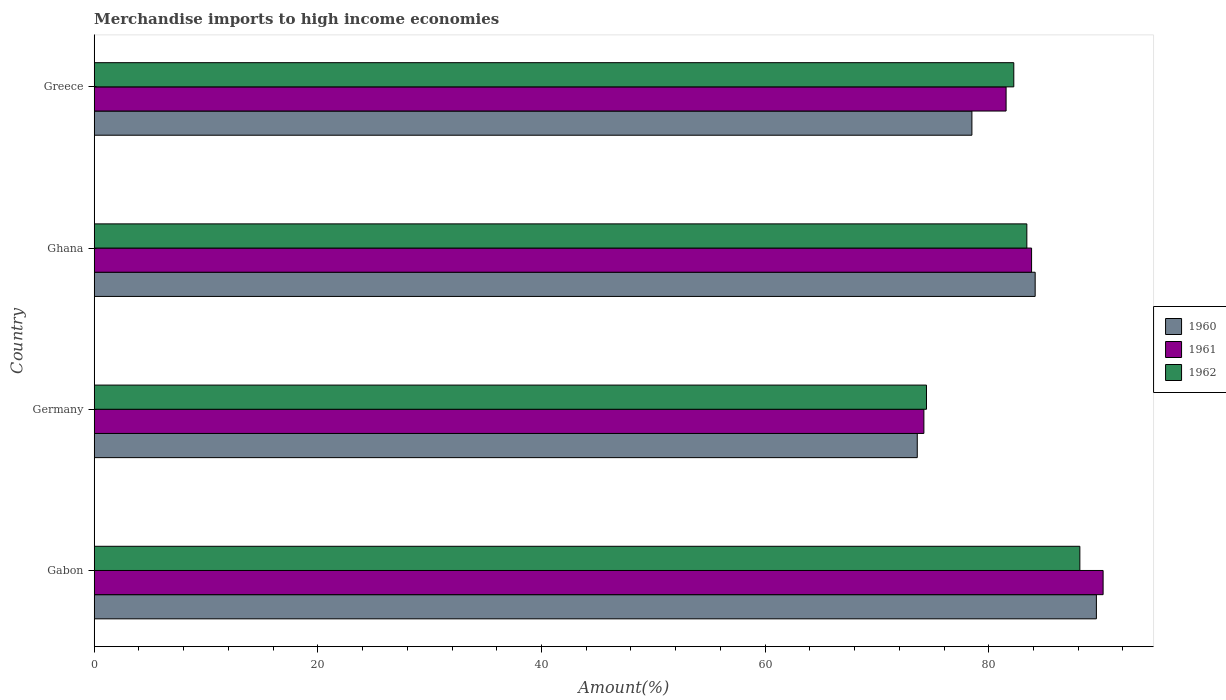How many groups of bars are there?
Ensure brevity in your answer.  4. Are the number of bars per tick equal to the number of legend labels?
Provide a short and direct response. Yes. What is the label of the 3rd group of bars from the top?
Ensure brevity in your answer.  Germany. What is the percentage of amount earned from merchandise imports in 1961 in Gabon?
Your answer should be compact. 90.22. Across all countries, what is the maximum percentage of amount earned from merchandise imports in 1961?
Offer a very short reply. 90.22. Across all countries, what is the minimum percentage of amount earned from merchandise imports in 1961?
Offer a very short reply. 74.2. In which country was the percentage of amount earned from merchandise imports in 1960 maximum?
Provide a short and direct response. Gabon. What is the total percentage of amount earned from merchandise imports in 1961 in the graph?
Offer a very short reply. 329.79. What is the difference between the percentage of amount earned from merchandise imports in 1961 in Gabon and that in Greece?
Offer a very short reply. 8.68. What is the difference between the percentage of amount earned from merchandise imports in 1961 in Gabon and the percentage of amount earned from merchandise imports in 1960 in Germany?
Offer a terse response. 16.62. What is the average percentage of amount earned from merchandise imports in 1960 per country?
Your response must be concise. 81.47. What is the difference between the percentage of amount earned from merchandise imports in 1962 and percentage of amount earned from merchandise imports in 1960 in Ghana?
Offer a very short reply. -0.74. In how many countries, is the percentage of amount earned from merchandise imports in 1960 greater than 52 %?
Provide a short and direct response. 4. What is the ratio of the percentage of amount earned from merchandise imports in 1960 in Germany to that in Greece?
Ensure brevity in your answer.  0.94. Is the percentage of amount earned from merchandise imports in 1961 in Gabon less than that in Greece?
Ensure brevity in your answer.  No. Is the difference between the percentage of amount earned from merchandise imports in 1962 in Gabon and Germany greater than the difference between the percentage of amount earned from merchandise imports in 1960 in Gabon and Germany?
Make the answer very short. No. What is the difference between the highest and the second highest percentage of amount earned from merchandise imports in 1961?
Your answer should be compact. 6.4. What is the difference between the highest and the lowest percentage of amount earned from merchandise imports in 1962?
Offer a terse response. 13.72. Is the sum of the percentage of amount earned from merchandise imports in 1962 in Germany and Ghana greater than the maximum percentage of amount earned from merchandise imports in 1960 across all countries?
Make the answer very short. Yes. What does the 2nd bar from the bottom in Greece represents?
Your response must be concise. 1961. Is it the case that in every country, the sum of the percentage of amount earned from merchandise imports in 1960 and percentage of amount earned from merchandise imports in 1962 is greater than the percentage of amount earned from merchandise imports in 1961?
Provide a short and direct response. Yes. How many bars are there?
Give a very brief answer. 12. Are all the bars in the graph horizontal?
Provide a short and direct response. Yes. What is the difference between two consecutive major ticks on the X-axis?
Offer a very short reply. 20. Are the values on the major ticks of X-axis written in scientific E-notation?
Your answer should be compact. No. Where does the legend appear in the graph?
Provide a succinct answer. Center right. How many legend labels are there?
Give a very brief answer. 3. How are the legend labels stacked?
Provide a succinct answer. Vertical. What is the title of the graph?
Your response must be concise. Merchandise imports to high income economies. What is the label or title of the X-axis?
Offer a very short reply. Amount(%). What is the Amount(%) in 1960 in Gabon?
Your answer should be very brief. 89.62. What is the Amount(%) of 1961 in Gabon?
Your answer should be very brief. 90.22. What is the Amount(%) of 1962 in Gabon?
Offer a very short reply. 88.14. What is the Amount(%) in 1960 in Germany?
Ensure brevity in your answer.  73.6. What is the Amount(%) in 1961 in Germany?
Your answer should be compact. 74.2. What is the Amount(%) in 1962 in Germany?
Provide a succinct answer. 74.43. What is the Amount(%) of 1960 in Ghana?
Make the answer very short. 84.15. What is the Amount(%) of 1961 in Ghana?
Your response must be concise. 83.83. What is the Amount(%) of 1962 in Ghana?
Your answer should be very brief. 83.4. What is the Amount(%) in 1960 in Greece?
Keep it short and to the point. 78.49. What is the Amount(%) in 1961 in Greece?
Keep it short and to the point. 81.55. What is the Amount(%) of 1962 in Greece?
Offer a terse response. 82.24. Across all countries, what is the maximum Amount(%) in 1960?
Make the answer very short. 89.62. Across all countries, what is the maximum Amount(%) in 1961?
Offer a very short reply. 90.22. Across all countries, what is the maximum Amount(%) of 1962?
Provide a short and direct response. 88.14. Across all countries, what is the minimum Amount(%) of 1960?
Ensure brevity in your answer.  73.6. Across all countries, what is the minimum Amount(%) in 1961?
Offer a very short reply. 74.2. Across all countries, what is the minimum Amount(%) in 1962?
Offer a terse response. 74.43. What is the total Amount(%) of 1960 in the graph?
Offer a very short reply. 325.87. What is the total Amount(%) of 1961 in the graph?
Provide a short and direct response. 329.79. What is the total Amount(%) of 1962 in the graph?
Provide a short and direct response. 328.21. What is the difference between the Amount(%) of 1960 in Gabon and that in Germany?
Make the answer very short. 16.02. What is the difference between the Amount(%) in 1961 in Gabon and that in Germany?
Make the answer very short. 16.03. What is the difference between the Amount(%) of 1962 in Gabon and that in Germany?
Your answer should be very brief. 13.72. What is the difference between the Amount(%) of 1960 in Gabon and that in Ghana?
Make the answer very short. 5.47. What is the difference between the Amount(%) of 1961 in Gabon and that in Ghana?
Ensure brevity in your answer.  6.4. What is the difference between the Amount(%) of 1962 in Gabon and that in Ghana?
Ensure brevity in your answer.  4.74. What is the difference between the Amount(%) of 1960 in Gabon and that in Greece?
Keep it short and to the point. 11.13. What is the difference between the Amount(%) of 1961 in Gabon and that in Greece?
Keep it short and to the point. 8.68. What is the difference between the Amount(%) in 1962 in Gabon and that in Greece?
Offer a terse response. 5.91. What is the difference between the Amount(%) of 1960 in Germany and that in Ghana?
Your answer should be compact. -10.54. What is the difference between the Amount(%) in 1961 in Germany and that in Ghana?
Provide a succinct answer. -9.63. What is the difference between the Amount(%) in 1962 in Germany and that in Ghana?
Ensure brevity in your answer.  -8.98. What is the difference between the Amount(%) in 1960 in Germany and that in Greece?
Provide a short and direct response. -4.89. What is the difference between the Amount(%) of 1961 in Germany and that in Greece?
Your answer should be very brief. -7.35. What is the difference between the Amount(%) in 1962 in Germany and that in Greece?
Provide a succinct answer. -7.81. What is the difference between the Amount(%) of 1960 in Ghana and that in Greece?
Keep it short and to the point. 5.66. What is the difference between the Amount(%) in 1961 in Ghana and that in Greece?
Provide a short and direct response. 2.28. What is the difference between the Amount(%) of 1962 in Ghana and that in Greece?
Your answer should be compact. 1.17. What is the difference between the Amount(%) of 1960 in Gabon and the Amount(%) of 1961 in Germany?
Your answer should be very brief. 15.43. What is the difference between the Amount(%) of 1960 in Gabon and the Amount(%) of 1962 in Germany?
Ensure brevity in your answer.  15.19. What is the difference between the Amount(%) in 1961 in Gabon and the Amount(%) in 1962 in Germany?
Provide a succinct answer. 15.8. What is the difference between the Amount(%) in 1960 in Gabon and the Amount(%) in 1961 in Ghana?
Your response must be concise. 5.8. What is the difference between the Amount(%) of 1960 in Gabon and the Amount(%) of 1962 in Ghana?
Offer a very short reply. 6.22. What is the difference between the Amount(%) in 1961 in Gabon and the Amount(%) in 1962 in Ghana?
Make the answer very short. 6.82. What is the difference between the Amount(%) of 1960 in Gabon and the Amount(%) of 1961 in Greece?
Offer a very short reply. 8.07. What is the difference between the Amount(%) of 1960 in Gabon and the Amount(%) of 1962 in Greece?
Make the answer very short. 7.39. What is the difference between the Amount(%) of 1961 in Gabon and the Amount(%) of 1962 in Greece?
Ensure brevity in your answer.  7.99. What is the difference between the Amount(%) of 1960 in Germany and the Amount(%) of 1961 in Ghana?
Provide a short and direct response. -10.22. What is the difference between the Amount(%) in 1960 in Germany and the Amount(%) in 1962 in Ghana?
Your response must be concise. -9.8. What is the difference between the Amount(%) in 1961 in Germany and the Amount(%) in 1962 in Ghana?
Your answer should be very brief. -9.21. What is the difference between the Amount(%) of 1960 in Germany and the Amount(%) of 1961 in Greece?
Your answer should be compact. -7.94. What is the difference between the Amount(%) in 1960 in Germany and the Amount(%) in 1962 in Greece?
Ensure brevity in your answer.  -8.63. What is the difference between the Amount(%) of 1961 in Germany and the Amount(%) of 1962 in Greece?
Ensure brevity in your answer.  -8.04. What is the difference between the Amount(%) in 1960 in Ghana and the Amount(%) in 1961 in Greece?
Your answer should be compact. 2.6. What is the difference between the Amount(%) in 1960 in Ghana and the Amount(%) in 1962 in Greece?
Your response must be concise. 1.91. What is the difference between the Amount(%) of 1961 in Ghana and the Amount(%) of 1962 in Greece?
Provide a succinct answer. 1.59. What is the average Amount(%) of 1960 per country?
Your answer should be very brief. 81.47. What is the average Amount(%) of 1961 per country?
Your response must be concise. 82.45. What is the average Amount(%) in 1962 per country?
Your response must be concise. 82.05. What is the difference between the Amount(%) in 1960 and Amount(%) in 1961 in Gabon?
Provide a succinct answer. -0.6. What is the difference between the Amount(%) of 1960 and Amount(%) of 1962 in Gabon?
Ensure brevity in your answer.  1.48. What is the difference between the Amount(%) in 1961 and Amount(%) in 1962 in Gabon?
Ensure brevity in your answer.  2.08. What is the difference between the Amount(%) in 1960 and Amount(%) in 1961 in Germany?
Your response must be concise. -0.59. What is the difference between the Amount(%) of 1960 and Amount(%) of 1962 in Germany?
Make the answer very short. -0.82. What is the difference between the Amount(%) in 1961 and Amount(%) in 1962 in Germany?
Keep it short and to the point. -0.23. What is the difference between the Amount(%) in 1960 and Amount(%) in 1961 in Ghana?
Give a very brief answer. 0.32. What is the difference between the Amount(%) of 1960 and Amount(%) of 1962 in Ghana?
Your answer should be very brief. 0.74. What is the difference between the Amount(%) in 1961 and Amount(%) in 1962 in Ghana?
Offer a very short reply. 0.42. What is the difference between the Amount(%) in 1960 and Amount(%) in 1961 in Greece?
Offer a very short reply. -3.06. What is the difference between the Amount(%) in 1960 and Amount(%) in 1962 in Greece?
Offer a terse response. -3.75. What is the difference between the Amount(%) of 1961 and Amount(%) of 1962 in Greece?
Your answer should be very brief. -0.69. What is the ratio of the Amount(%) of 1960 in Gabon to that in Germany?
Give a very brief answer. 1.22. What is the ratio of the Amount(%) of 1961 in Gabon to that in Germany?
Your response must be concise. 1.22. What is the ratio of the Amount(%) in 1962 in Gabon to that in Germany?
Provide a short and direct response. 1.18. What is the ratio of the Amount(%) of 1960 in Gabon to that in Ghana?
Provide a short and direct response. 1.07. What is the ratio of the Amount(%) of 1961 in Gabon to that in Ghana?
Provide a short and direct response. 1.08. What is the ratio of the Amount(%) of 1962 in Gabon to that in Ghana?
Your answer should be compact. 1.06. What is the ratio of the Amount(%) of 1960 in Gabon to that in Greece?
Provide a short and direct response. 1.14. What is the ratio of the Amount(%) of 1961 in Gabon to that in Greece?
Keep it short and to the point. 1.11. What is the ratio of the Amount(%) in 1962 in Gabon to that in Greece?
Offer a very short reply. 1.07. What is the ratio of the Amount(%) in 1960 in Germany to that in Ghana?
Offer a very short reply. 0.87. What is the ratio of the Amount(%) of 1961 in Germany to that in Ghana?
Offer a very short reply. 0.89. What is the ratio of the Amount(%) of 1962 in Germany to that in Ghana?
Offer a very short reply. 0.89. What is the ratio of the Amount(%) in 1960 in Germany to that in Greece?
Provide a short and direct response. 0.94. What is the ratio of the Amount(%) of 1961 in Germany to that in Greece?
Provide a succinct answer. 0.91. What is the ratio of the Amount(%) in 1962 in Germany to that in Greece?
Keep it short and to the point. 0.91. What is the ratio of the Amount(%) of 1960 in Ghana to that in Greece?
Your answer should be compact. 1.07. What is the ratio of the Amount(%) of 1961 in Ghana to that in Greece?
Provide a short and direct response. 1.03. What is the ratio of the Amount(%) of 1962 in Ghana to that in Greece?
Provide a succinct answer. 1.01. What is the difference between the highest and the second highest Amount(%) of 1960?
Provide a short and direct response. 5.47. What is the difference between the highest and the second highest Amount(%) in 1961?
Give a very brief answer. 6.4. What is the difference between the highest and the second highest Amount(%) of 1962?
Provide a succinct answer. 4.74. What is the difference between the highest and the lowest Amount(%) of 1960?
Your response must be concise. 16.02. What is the difference between the highest and the lowest Amount(%) in 1961?
Give a very brief answer. 16.03. What is the difference between the highest and the lowest Amount(%) in 1962?
Ensure brevity in your answer.  13.72. 